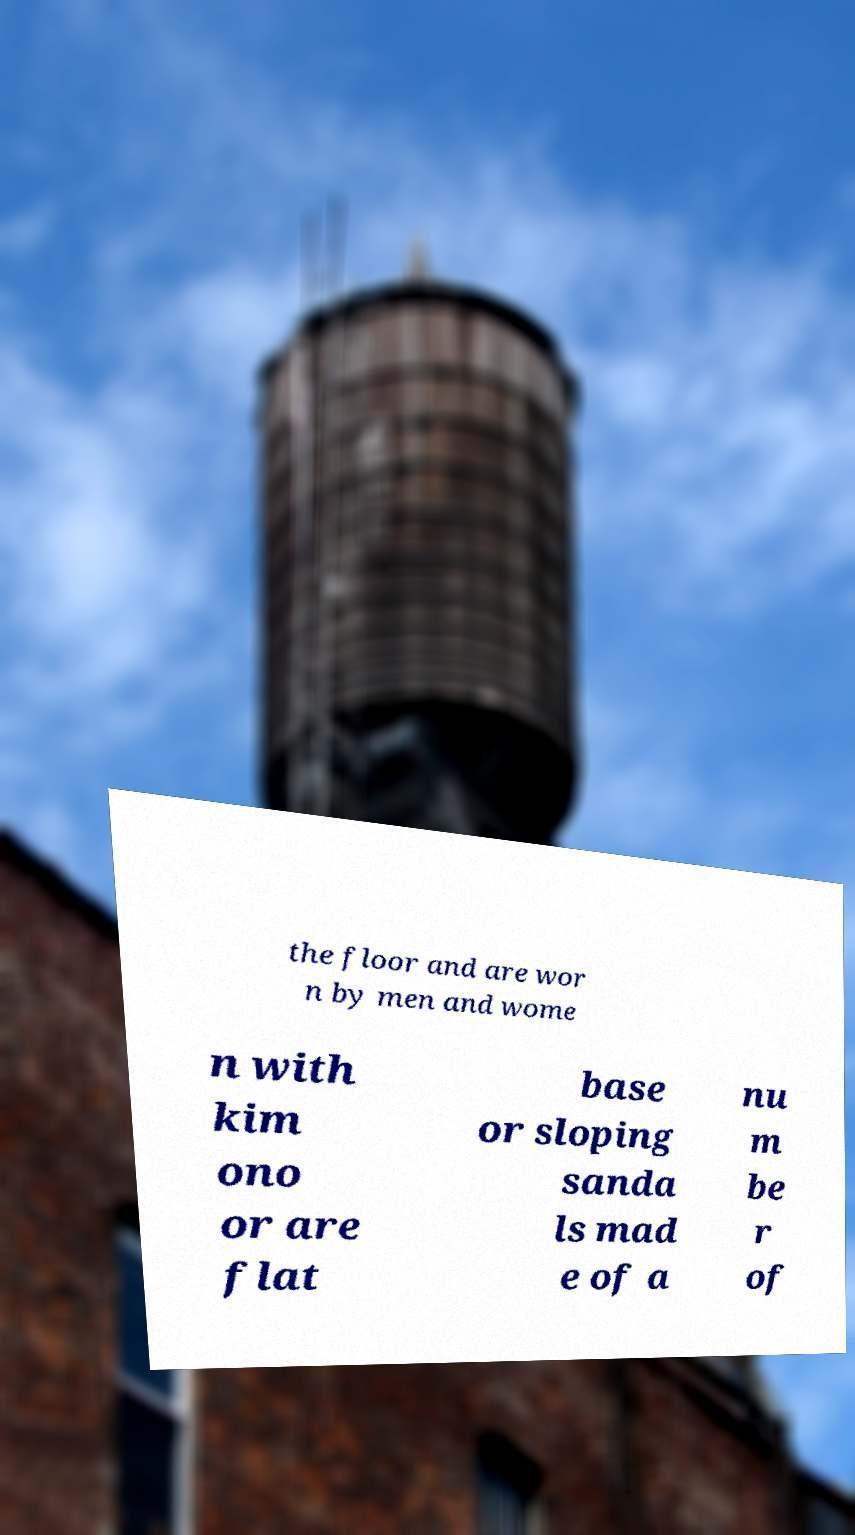What messages or text are displayed in this image? I need them in a readable, typed format. the floor and are wor n by men and wome n with kim ono or are flat base or sloping sanda ls mad e of a nu m be r of 